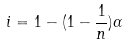<formula> <loc_0><loc_0><loc_500><loc_500>i = 1 - ( 1 - \frac { 1 } { n } ) \alpha</formula> 